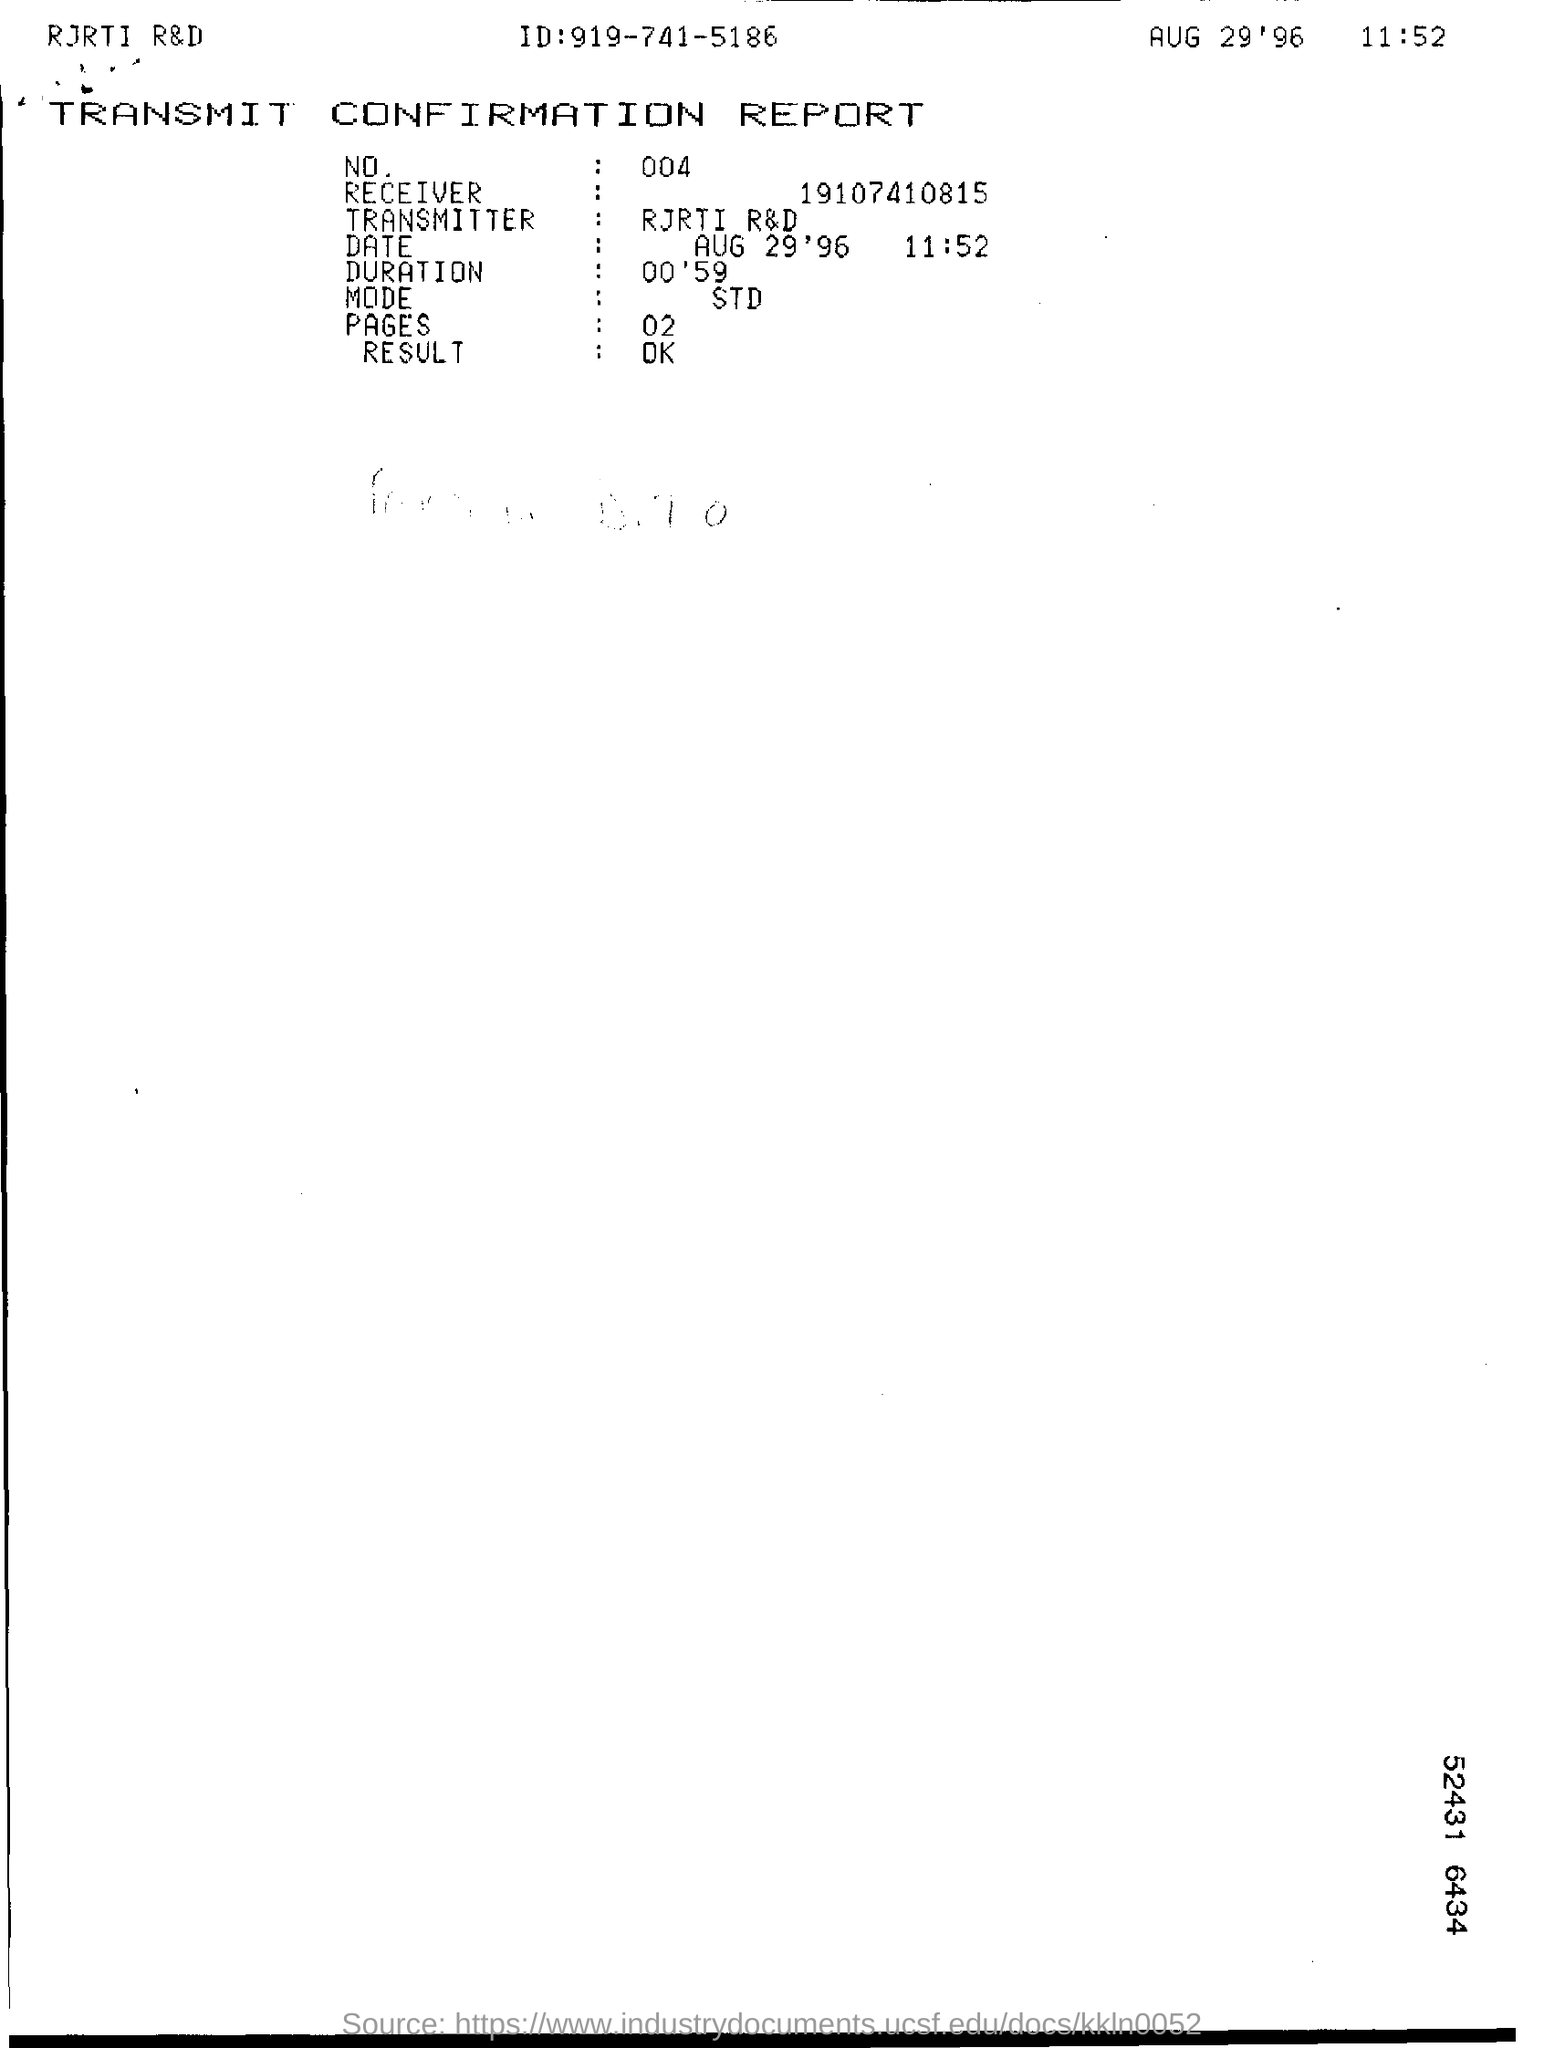Which report is this ?
Your answer should be compact. Transmit confirmation report. 